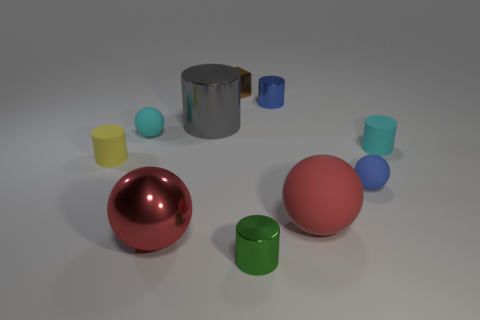Are there any patterns or symmetry in the arrangement of objects? The arrangement of objects doesn't exhibit any precise patterns or symmetry; the items are placed in a seemingly arbitrary manner across the surface. 